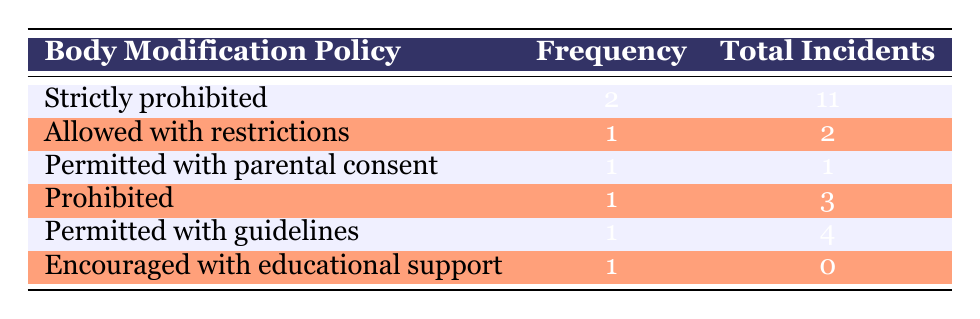What is the most common body modification policy among the schools listed? The most common body modification policy is "Strictly prohibited," which appears in 2 out of 7 schools.
Answer: Strictly prohibited How many total incidents of body modification were recorded across all schools? To find the total incidents, sum the values in the "Total Incidents" column: 11 (Strictly prohibited) + 2 (Allowed with restrictions) + 1 (Permitted with parental consent) + 3 (Prohibited) + 4 (Permitted with guidelines) + 0 (Encouraged with educational support) = 21.
Answer: 21 Is it true that there are more schools that prohibit body modification than allow it with restrictions? There are 2 schools that prohibit body modification (Strictly prohibited) and 1 school that allows it with restrictions, so it is true.
Answer: Yes What is the average number of incidents for schools that have body modification policies permitted with conditions (like guidelines or parental consent)? The schools permitted with conditions are "Permitted with parental consent" (1 incident) and "Permitted with guidelines" (4 incidents). Adding these gives 1 + 4 = 5. There are 2 such schools, so the average is 5/2 = 2.5.
Answer: 2.5 Which policy has the least number of incidents, and how many incidents were reported? The policy with the least number of incidents is "Encouraged with educational support," which has reported 0 incidents.
Answer: 0 What is the difference in the number of incidents between schools with "Strictly prohibited" and those "Permitted with guidelines"? The sum of incidents for "Strictly prohibited" is 11, and for "Permitted with guidelines" it is 4. The difference is 11 - 4 = 7.
Answer: 7 How many schools have a body modification policy that allows for some form of body modification? There are 3 schools that allow some form of body modification: "Allowed with restrictions," "Permitted with parental consent," and "Permitted with guidelines."
Answer: 3 